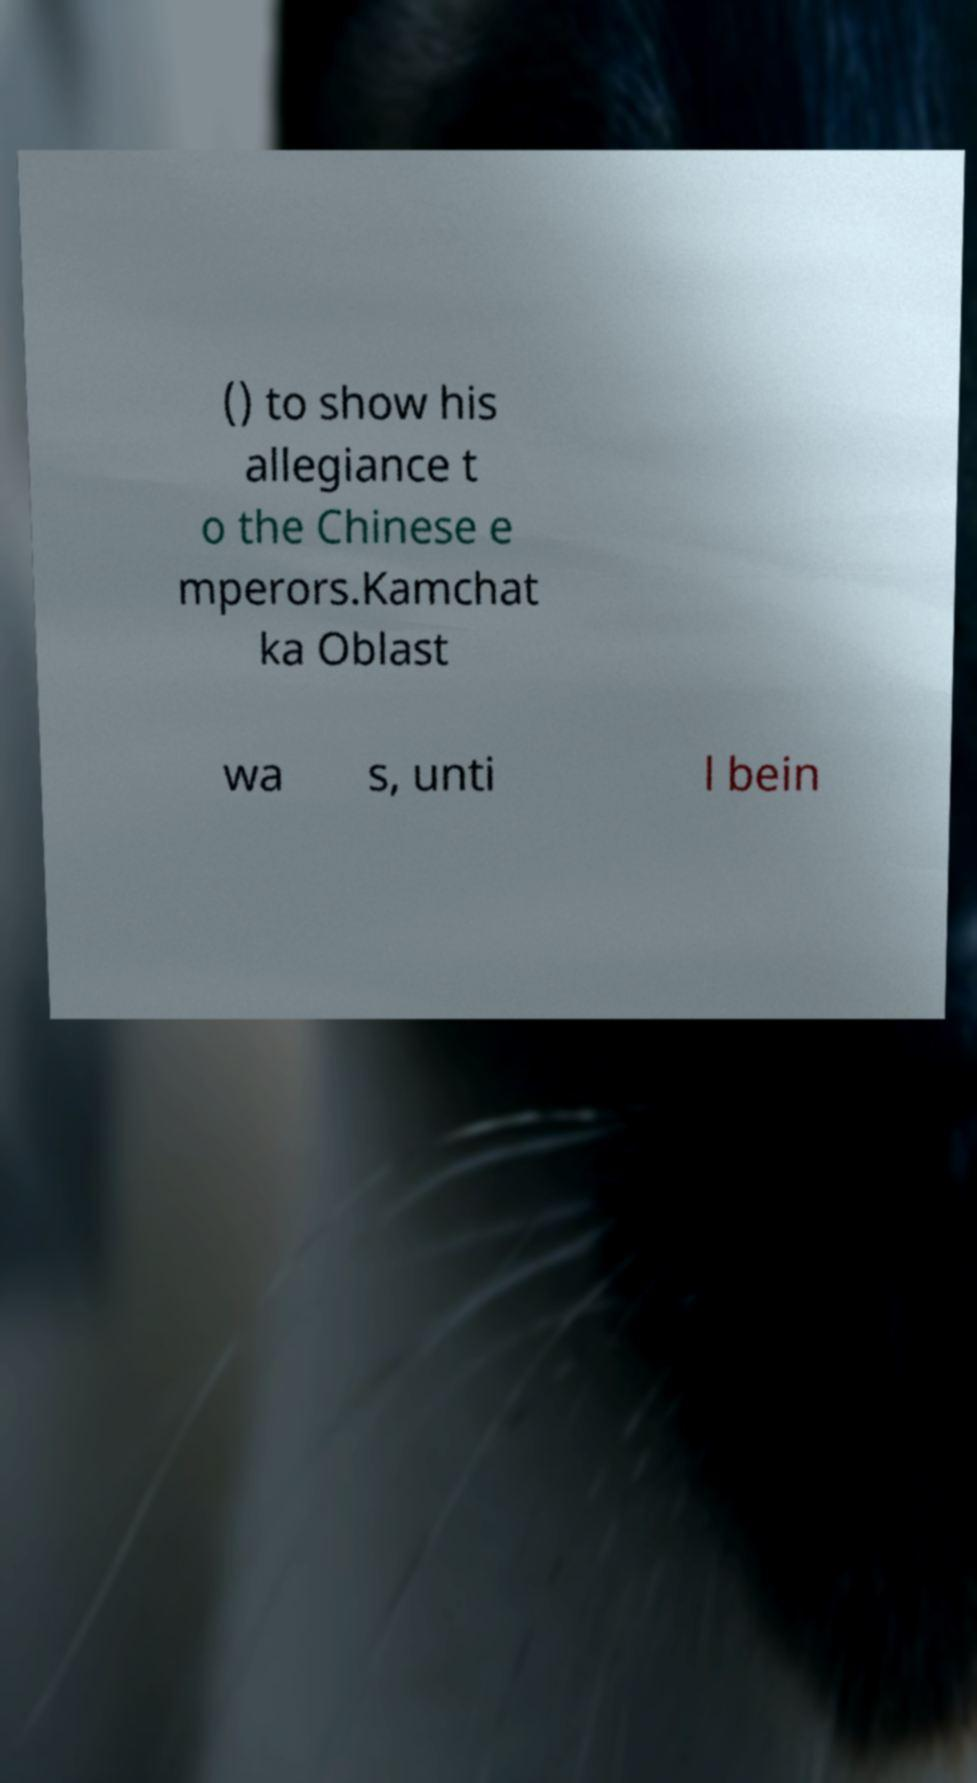What messages or text are displayed in this image? I need them in a readable, typed format. () to show his allegiance t o the Chinese e mperors.Kamchat ka Oblast wa s, unti l bein 